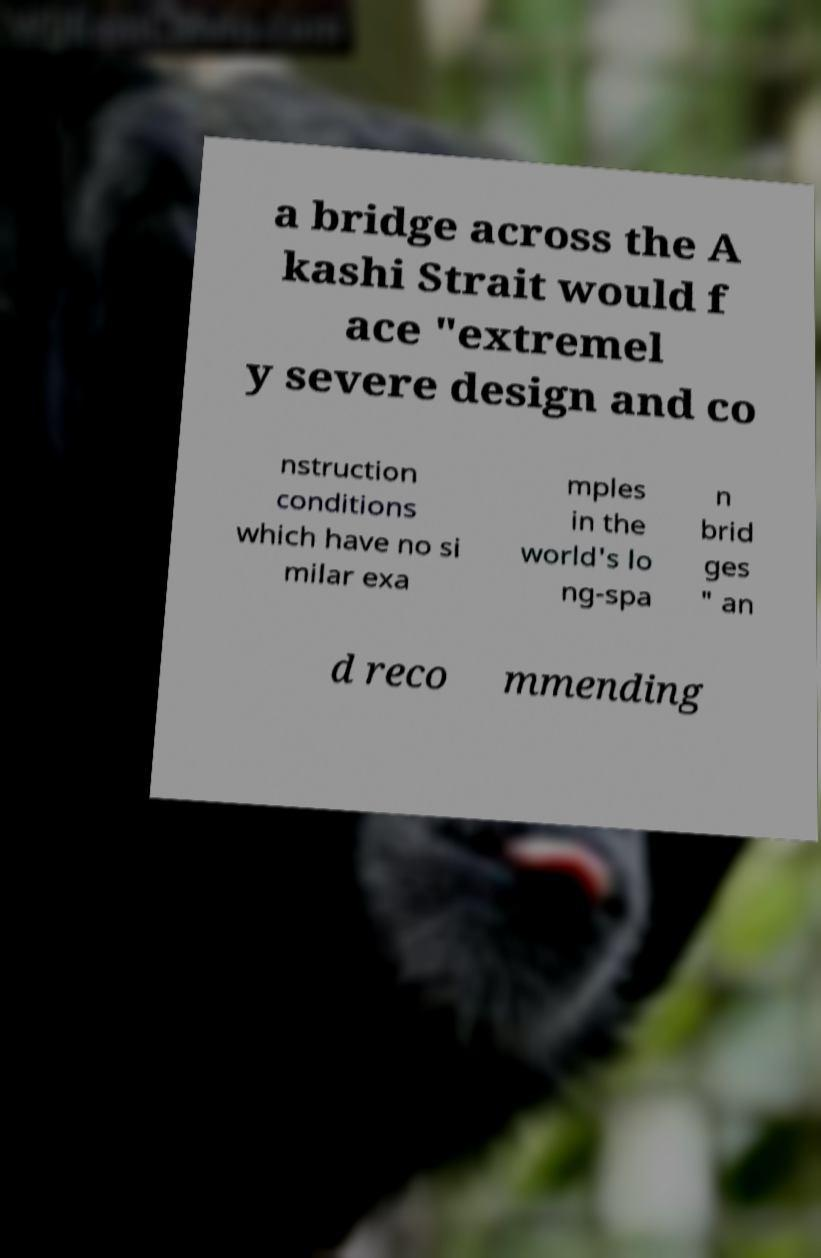There's text embedded in this image that I need extracted. Can you transcribe it verbatim? a bridge across the A kashi Strait would f ace "extremel y severe design and co nstruction conditions which have no si milar exa mples in the world's lo ng-spa n brid ges " an d reco mmending 